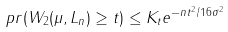<formula> <loc_0><loc_0><loc_500><loc_500>\ p r ( W _ { 2 } ( \mu , L _ { n } ) \geq t ) \leq K _ { t } e ^ { - n t ^ { 2 } / 1 6 \sigma ^ { 2 } }</formula> 